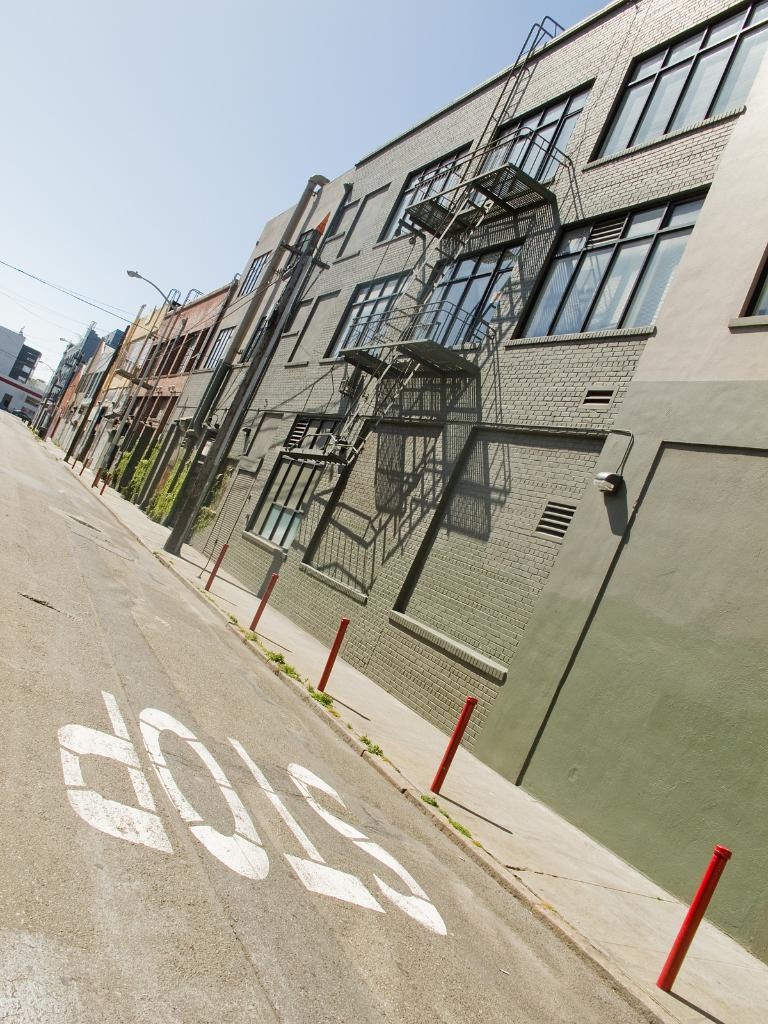What type of structures are present in the image? There are buildings with windows in the image. What feature do the buildings have? The buildings have stairs. What can be seen running through the image? There is a road visible in the image. What objects are present on the footpath? There are poles on the footpath. What part of the natural environment is visible in the image? The sky is visible in the background of the image. What type of art can be seen on the buildings in the image? There is no art visible on the buildings in the image. What is the needle used for in the image? There is no needle present in the image. 